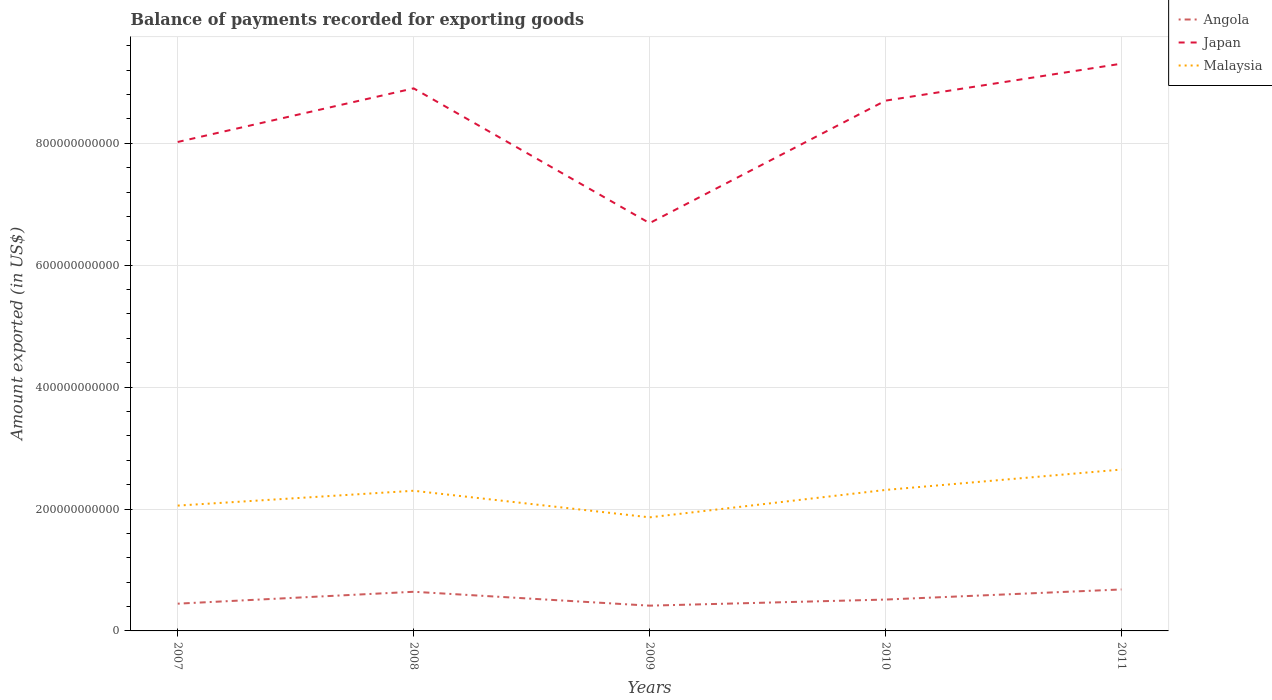How many different coloured lines are there?
Give a very brief answer. 3. Does the line corresponding to Japan intersect with the line corresponding to Angola?
Ensure brevity in your answer.  No. Across all years, what is the maximum amount exported in Angola?
Offer a terse response. 4.15e+1. In which year was the amount exported in Japan maximum?
Offer a very short reply. 2009. What is the total amount exported in Japan in the graph?
Ensure brevity in your answer.  1.33e+11. What is the difference between the highest and the second highest amount exported in Malaysia?
Offer a terse response. 7.84e+1. How many lines are there?
Offer a very short reply. 3. What is the difference between two consecutive major ticks on the Y-axis?
Offer a very short reply. 2.00e+11. Does the graph contain grids?
Provide a short and direct response. Yes. What is the title of the graph?
Provide a short and direct response. Balance of payments recorded for exporting goods. Does "Vanuatu" appear as one of the legend labels in the graph?
Your answer should be very brief. No. What is the label or title of the Y-axis?
Your answer should be very brief. Amount exported (in US$). What is the Amount exported (in US$) of Angola in 2007?
Your answer should be compact. 4.47e+1. What is the Amount exported (in US$) in Japan in 2007?
Offer a terse response. 8.02e+11. What is the Amount exported (in US$) of Malaysia in 2007?
Give a very brief answer. 2.06e+11. What is the Amount exported (in US$) of Angola in 2008?
Provide a succinct answer. 6.42e+1. What is the Amount exported (in US$) in Japan in 2008?
Make the answer very short. 8.90e+11. What is the Amount exported (in US$) of Malaysia in 2008?
Your answer should be very brief. 2.30e+11. What is the Amount exported (in US$) of Angola in 2009?
Ensure brevity in your answer.  4.15e+1. What is the Amount exported (in US$) in Japan in 2009?
Make the answer very short. 6.69e+11. What is the Amount exported (in US$) of Malaysia in 2009?
Give a very brief answer. 1.86e+11. What is the Amount exported (in US$) in Angola in 2010?
Offer a very short reply. 5.15e+1. What is the Amount exported (in US$) of Japan in 2010?
Keep it short and to the point. 8.70e+11. What is the Amount exported (in US$) of Malaysia in 2010?
Your answer should be very brief. 2.31e+11. What is the Amount exported (in US$) of Angola in 2011?
Your answer should be compact. 6.80e+1. What is the Amount exported (in US$) in Japan in 2011?
Provide a succinct answer. 9.31e+11. What is the Amount exported (in US$) in Malaysia in 2011?
Keep it short and to the point. 2.65e+11. Across all years, what is the maximum Amount exported (in US$) of Angola?
Your response must be concise. 6.80e+1. Across all years, what is the maximum Amount exported (in US$) of Japan?
Offer a terse response. 9.31e+11. Across all years, what is the maximum Amount exported (in US$) in Malaysia?
Keep it short and to the point. 2.65e+11. Across all years, what is the minimum Amount exported (in US$) in Angola?
Your answer should be very brief. 4.15e+1. Across all years, what is the minimum Amount exported (in US$) in Japan?
Offer a terse response. 6.69e+11. Across all years, what is the minimum Amount exported (in US$) in Malaysia?
Offer a terse response. 1.86e+11. What is the total Amount exported (in US$) in Angola in the graph?
Ensure brevity in your answer.  2.70e+11. What is the total Amount exported (in US$) of Japan in the graph?
Provide a short and direct response. 4.16e+12. What is the total Amount exported (in US$) of Malaysia in the graph?
Give a very brief answer. 1.12e+12. What is the difference between the Amount exported (in US$) of Angola in 2007 and that in 2008?
Your answer should be compact. -1.95e+1. What is the difference between the Amount exported (in US$) in Japan in 2007 and that in 2008?
Your response must be concise. -8.80e+1. What is the difference between the Amount exported (in US$) of Malaysia in 2007 and that in 2008?
Give a very brief answer. -2.44e+1. What is the difference between the Amount exported (in US$) of Angola in 2007 and that in 2009?
Give a very brief answer. 3.26e+09. What is the difference between the Amount exported (in US$) in Japan in 2007 and that in 2009?
Your answer should be very brief. 1.33e+11. What is the difference between the Amount exported (in US$) in Malaysia in 2007 and that in 2009?
Your answer should be compact. 1.93e+1. What is the difference between the Amount exported (in US$) in Angola in 2007 and that in 2010?
Make the answer very short. -6.74e+09. What is the difference between the Amount exported (in US$) of Japan in 2007 and that in 2010?
Offer a terse response. -6.78e+1. What is the difference between the Amount exported (in US$) of Malaysia in 2007 and that in 2010?
Offer a terse response. -2.57e+1. What is the difference between the Amount exported (in US$) of Angola in 2007 and that in 2011?
Provide a short and direct response. -2.33e+1. What is the difference between the Amount exported (in US$) in Japan in 2007 and that in 2011?
Offer a terse response. -1.28e+11. What is the difference between the Amount exported (in US$) in Malaysia in 2007 and that in 2011?
Offer a terse response. -5.92e+1. What is the difference between the Amount exported (in US$) of Angola in 2008 and that in 2009?
Your response must be concise. 2.28e+1. What is the difference between the Amount exported (in US$) in Japan in 2008 and that in 2009?
Your answer should be very brief. 2.21e+11. What is the difference between the Amount exported (in US$) in Malaysia in 2008 and that in 2009?
Give a very brief answer. 4.36e+1. What is the difference between the Amount exported (in US$) of Angola in 2008 and that in 2010?
Your answer should be compact. 1.28e+1. What is the difference between the Amount exported (in US$) of Japan in 2008 and that in 2010?
Offer a very short reply. 2.02e+1. What is the difference between the Amount exported (in US$) in Malaysia in 2008 and that in 2010?
Give a very brief answer. -1.34e+09. What is the difference between the Amount exported (in US$) in Angola in 2008 and that in 2011?
Give a very brief answer. -3.80e+09. What is the difference between the Amount exported (in US$) in Japan in 2008 and that in 2011?
Your answer should be compact. -4.05e+1. What is the difference between the Amount exported (in US$) of Malaysia in 2008 and that in 2011?
Your answer should be very brief. -3.48e+1. What is the difference between the Amount exported (in US$) in Angola in 2009 and that in 2010?
Offer a very short reply. -1.00e+1. What is the difference between the Amount exported (in US$) in Japan in 2009 and that in 2010?
Offer a terse response. -2.01e+11. What is the difference between the Amount exported (in US$) of Malaysia in 2009 and that in 2010?
Ensure brevity in your answer.  -4.50e+1. What is the difference between the Amount exported (in US$) of Angola in 2009 and that in 2011?
Ensure brevity in your answer.  -2.66e+1. What is the difference between the Amount exported (in US$) in Japan in 2009 and that in 2011?
Ensure brevity in your answer.  -2.62e+11. What is the difference between the Amount exported (in US$) in Malaysia in 2009 and that in 2011?
Ensure brevity in your answer.  -7.84e+1. What is the difference between the Amount exported (in US$) of Angola in 2010 and that in 2011?
Give a very brief answer. -1.66e+1. What is the difference between the Amount exported (in US$) of Japan in 2010 and that in 2011?
Provide a short and direct response. -6.07e+1. What is the difference between the Amount exported (in US$) of Malaysia in 2010 and that in 2011?
Your answer should be compact. -3.35e+1. What is the difference between the Amount exported (in US$) in Angola in 2007 and the Amount exported (in US$) in Japan in 2008?
Offer a terse response. -8.45e+11. What is the difference between the Amount exported (in US$) of Angola in 2007 and the Amount exported (in US$) of Malaysia in 2008?
Give a very brief answer. -1.85e+11. What is the difference between the Amount exported (in US$) of Japan in 2007 and the Amount exported (in US$) of Malaysia in 2008?
Offer a terse response. 5.72e+11. What is the difference between the Amount exported (in US$) in Angola in 2007 and the Amount exported (in US$) in Japan in 2009?
Make the answer very short. -6.24e+11. What is the difference between the Amount exported (in US$) in Angola in 2007 and the Amount exported (in US$) in Malaysia in 2009?
Your answer should be compact. -1.42e+11. What is the difference between the Amount exported (in US$) of Japan in 2007 and the Amount exported (in US$) of Malaysia in 2009?
Provide a short and direct response. 6.16e+11. What is the difference between the Amount exported (in US$) of Angola in 2007 and the Amount exported (in US$) of Japan in 2010?
Provide a succinct answer. -8.25e+11. What is the difference between the Amount exported (in US$) in Angola in 2007 and the Amount exported (in US$) in Malaysia in 2010?
Provide a short and direct response. -1.87e+11. What is the difference between the Amount exported (in US$) of Japan in 2007 and the Amount exported (in US$) of Malaysia in 2010?
Your response must be concise. 5.71e+11. What is the difference between the Amount exported (in US$) of Angola in 2007 and the Amount exported (in US$) of Japan in 2011?
Your answer should be compact. -8.86e+11. What is the difference between the Amount exported (in US$) of Angola in 2007 and the Amount exported (in US$) of Malaysia in 2011?
Give a very brief answer. -2.20e+11. What is the difference between the Amount exported (in US$) in Japan in 2007 and the Amount exported (in US$) in Malaysia in 2011?
Your answer should be very brief. 5.37e+11. What is the difference between the Amount exported (in US$) of Angola in 2008 and the Amount exported (in US$) of Japan in 2009?
Keep it short and to the point. -6.05e+11. What is the difference between the Amount exported (in US$) in Angola in 2008 and the Amount exported (in US$) in Malaysia in 2009?
Provide a short and direct response. -1.22e+11. What is the difference between the Amount exported (in US$) of Japan in 2008 and the Amount exported (in US$) of Malaysia in 2009?
Provide a succinct answer. 7.04e+11. What is the difference between the Amount exported (in US$) in Angola in 2008 and the Amount exported (in US$) in Japan in 2010?
Offer a very short reply. -8.06e+11. What is the difference between the Amount exported (in US$) in Angola in 2008 and the Amount exported (in US$) in Malaysia in 2010?
Your response must be concise. -1.67e+11. What is the difference between the Amount exported (in US$) of Japan in 2008 and the Amount exported (in US$) of Malaysia in 2010?
Your response must be concise. 6.59e+11. What is the difference between the Amount exported (in US$) in Angola in 2008 and the Amount exported (in US$) in Japan in 2011?
Provide a succinct answer. -8.66e+11. What is the difference between the Amount exported (in US$) in Angola in 2008 and the Amount exported (in US$) in Malaysia in 2011?
Provide a short and direct response. -2.01e+11. What is the difference between the Amount exported (in US$) of Japan in 2008 and the Amount exported (in US$) of Malaysia in 2011?
Provide a succinct answer. 6.25e+11. What is the difference between the Amount exported (in US$) in Angola in 2009 and the Amount exported (in US$) in Japan in 2010?
Give a very brief answer. -8.29e+11. What is the difference between the Amount exported (in US$) of Angola in 2009 and the Amount exported (in US$) of Malaysia in 2010?
Provide a short and direct response. -1.90e+11. What is the difference between the Amount exported (in US$) of Japan in 2009 and the Amount exported (in US$) of Malaysia in 2010?
Your answer should be very brief. 4.38e+11. What is the difference between the Amount exported (in US$) in Angola in 2009 and the Amount exported (in US$) in Japan in 2011?
Ensure brevity in your answer.  -8.89e+11. What is the difference between the Amount exported (in US$) in Angola in 2009 and the Amount exported (in US$) in Malaysia in 2011?
Your answer should be very brief. -2.23e+11. What is the difference between the Amount exported (in US$) of Japan in 2009 and the Amount exported (in US$) of Malaysia in 2011?
Give a very brief answer. 4.04e+11. What is the difference between the Amount exported (in US$) of Angola in 2010 and the Amount exported (in US$) of Japan in 2011?
Offer a very short reply. -8.79e+11. What is the difference between the Amount exported (in US$) of Angola in 2010 and the Amount exported (in US$) of Malaysia in 2011?
Provide a short and direct response. -2.13e+11. What is the difference between the Amount exported (in US$) in Japan in 2010 and the Amount exported (in US$) in Malaysia in 2011?
Offer a very short reply. 6.05e+11. What is the average Amount exported (in US$) of Angola per year?
Keep it short and to the point. 5.40e+1. What is the average Amount exported (in US$) of Japan per year?
Offer a terse response. 8.32e+11. What is the average Amount exported (in US$) of Malaysia per year?
Make the answer very short. 2.24e+11. In the year 2007, what is the difference between the Amount exported (in US$) of Angola and Amount exported (in US$) of Japan?
Give a very brief answer. -7.57e+11. In the year 2007, what is the difference between the Amount exported (in US$) in Angola and Amount exported (in US$) in Malaysia?
Keep it short and to the point. -1.61e+11. In the year 2007, what is the difference between the Amount exported (in US$) of Japan and Amount exported (in US$) of Malaysia?
Provide a succinct answer. 5.97e+11. In the year 2008, what is the difference between the Amount exported (in US$) in Angola and Amount exported (in US$) in Japan?
Provide a succinct answer. -8.26e+11. In the year 2008, what is the difference between the Amount exported (in US$) in Angola and Amount exported (in US$) in Malaysia?
Ensure brevity in your answer.  -1.66e+11. In the year 2008, what is the difference between the Amount exported (in US$) of Japan and Amount exported (in US$) of Malaysia?
Offer a terse response. 6.60e+11. In the year 2009, what is the difference between the Amount exported (in US$) in Angola and Amount exported (in US$) in Japan?
Ensure brevity in your answer.  -6.28e+11. In the year 2009, what is the difference between the Amount exported (in US$) in Angola and Amount exported (in US$) in Malaysia?
Provide a short and direct response. -1.45e+11. In the year 2009, what is the difference between the Amount exported (in US$) in Japan and Amount exported (in US$) in Malaysia?
Provide a succinct answer. 4.83e+11. In the year 2010, what is the difference between the Amount exported (in US$) in Angola and Amount exported (in US$) in Japan?
Offer a terse response. -8.19e+11. In the year 2010, what is the difference between the Amount exported (in US$) of Angola and Amount exported (in US$) of Malaysia?
Your answer should be very brief. -1.80e+11. In the year 2010, what is the difference between the Amount exported (in US$) of Japan and Amount exported (in US$) of Malaysia?
Keep it short and to the point. 6.39e+11. In the year 2011, what is the difference between the Amount exported (in US$) of Angola and Amount exported (in US$) of Japan?
Give a very brief answer. -8.63e+11. In the year 2011, what is the difference between the Amount exported (in US$) in Angola and Amount exported (in US$) in Malaysia?
Provide a succinct answer. -1.97e+11. In the year 2011, what is the difference between the Amount exported (in US$) in Japan and Amount exported (in US$) in Malaysia?
Your response must be concise. 6.66e+11. What is the ratio of the Amount exported (in US$) in Angola in 2007 to that in 2008?
Your answer should be very brief. 0.7. What is the ratio of the Amount exported (in US$) in Japan in 2007 to that in 2008?
Make the answer very short. 0.9. What is the ratio of the Amount exported (in US$) in Malaysia in 2007 to that in 2008?
Ensure brevity in your answer.  0.89. What is the ratio of the Amount exported (in US$) in Angola in 2007 to that in 2009?
Offer a very short reply. 1.08. What is the ratio of the Amount exported (in US$) of Japan in 2007 to that in 2009?
Your answer should be compact. 1.2. What is the ratio of the Amount exported (in US$) in Malaysia in 2007 to that in 2009?
Your answer should be very brief. 1.1. What is the ratio of the Amount exported (in US$) in Angola in 2007 to that in 2010?
Give a very brief answer. 0.87. What is the ratio of the Amount exported (in US$) of Japan in 2007 to that in 2010?
Ensure brevity in your answer.  0.92. What is the ratio of the Amount exported (in US$) in Angola in 2007 to that in 2011?
Ensure brevity in your answer.  0.66. What is the ratio of the Amount exported (in US$) of Japan in 2007 to that in 2011?
Offer a terse response. 0.86. What is the ratio of the Amount exported (in US$) of Malaysia in 2007 to that in 2011?
Make the answer very short. 0.78. What is the ratio of the Amount exported (in US$) in Angola in 2008 to that in 2009?
Offer a terse response. 1.55. What is the ratio of the Amount exported (in US$) of Japan in 2008 to that in 2009?
Provide a short and direct response. 1.33. What is the ratio of the Amount exported (in US$) in Malaysia in 2008 to that in 2009?
Provide a short and direct response. 1.23. What is the ratio of the Amount exported (in US$) in Angola in 2008 to that in 2010?
Keep it short and to the point. 1.25. What is the ratio of the Amount exported (in US$) of Japan in 2008 to that in 2010?
Provide a succinct answer. 1.02. What is the ratio of the Amount exported (in US$) of Angola in 2008 to that in 2011?
Your answer should be compact. 0.94. What is the ratio of the Amount exported (in US$) of Japan in 2008 to that in 2011?
Offer a terse response. 0.96. What is the ratio of the Amount exported (in US$) of Malaysia in 2008 to that in 2011?
Make the answer very short. 0.87. What is the ratio of the Amount exported (in US$) in Angola in 2009 to that in 2010?
Keep it short and to the point. 0.81. What is the ratio of the Amount exported (in US$) in Japan in 2009 to that in 2010?
Make the answer very short. 0.77. What is the ratio of the Amount exported (in US$) in Malaysia in 2009 to that in 2010?
Offer a very short reply. 0.81. What is the ratio of the Amount exported (in US$) of Angola in 2009 to that in 2011?
Offer a very short reply. 0.61. What is the ratio of the Amount exported (in US$) of Japan in 2009 to that in 2011?
Give a very brief answer. 0.72. What is the ratio of the Amount exported (in US$) in Malaysia in 2009 to that in 2011?
Make the answer very short. 0.7. What is the ratio of the Amount exported (in US$) of Angola in 2010 to that in 2011?
Offer a very short reply. 0.76. What is the ratio of the Amount exported (in US$) of Japan in 2010 to that in 2011?
Offer a very short reply. 0.93. What is the ratio of the Amount exported (in US$) of Malaysia in 2010 to that in 2011?
Give a very brief answer. 0.87. What is the difference between the highest and the second highest Amount exported (in US$) in Angola?
Ensure brevity in your answer.  3.80e+09. What is the difference between the highest and the second highest Amount exported (in US$) in Japan?
Offer a very short reply. 4.05e+1. What is the difference between the highest and the second highest Amount exported (in US$) of Malaysia?
Your response must be concise. 3.35e+1. What is the difference between the highest and the lowest Amount exported (in US$) in Angola?
Your response must be concise. 2.66e+1. What is the difference between the highest and the lowest Amount exported (in US$) of Japan?
Keep it short and to the point. 2.62e+11. What is the difference between the highest and the lowest Amount exported (in US$) of Malaysia?
Ensure brevity in your answer.  7.84e+1. 